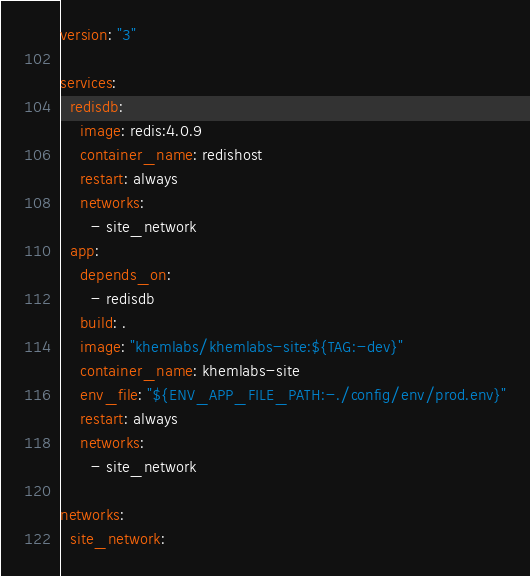<code> <loc_0><loc_0><loc_500><loc_500><_YAML_>version: "3" 

services:
  redisdb:
    image: redis:4.0.9
    container_name: redishost
    restart: always
    networks:
      - site_network
  app:
    depends_on:
      - redisdb
    build: .
    image: "khemlabs/khemlabs-site:${TAG:-dev}"
    container_name: khemlabs-site
    env_file: "${ENV_APP_FILE_PATH:-./config/env/prod.env}"
    restart: always
    networks:
      - site_network

networks:
  site_network:
</code> 